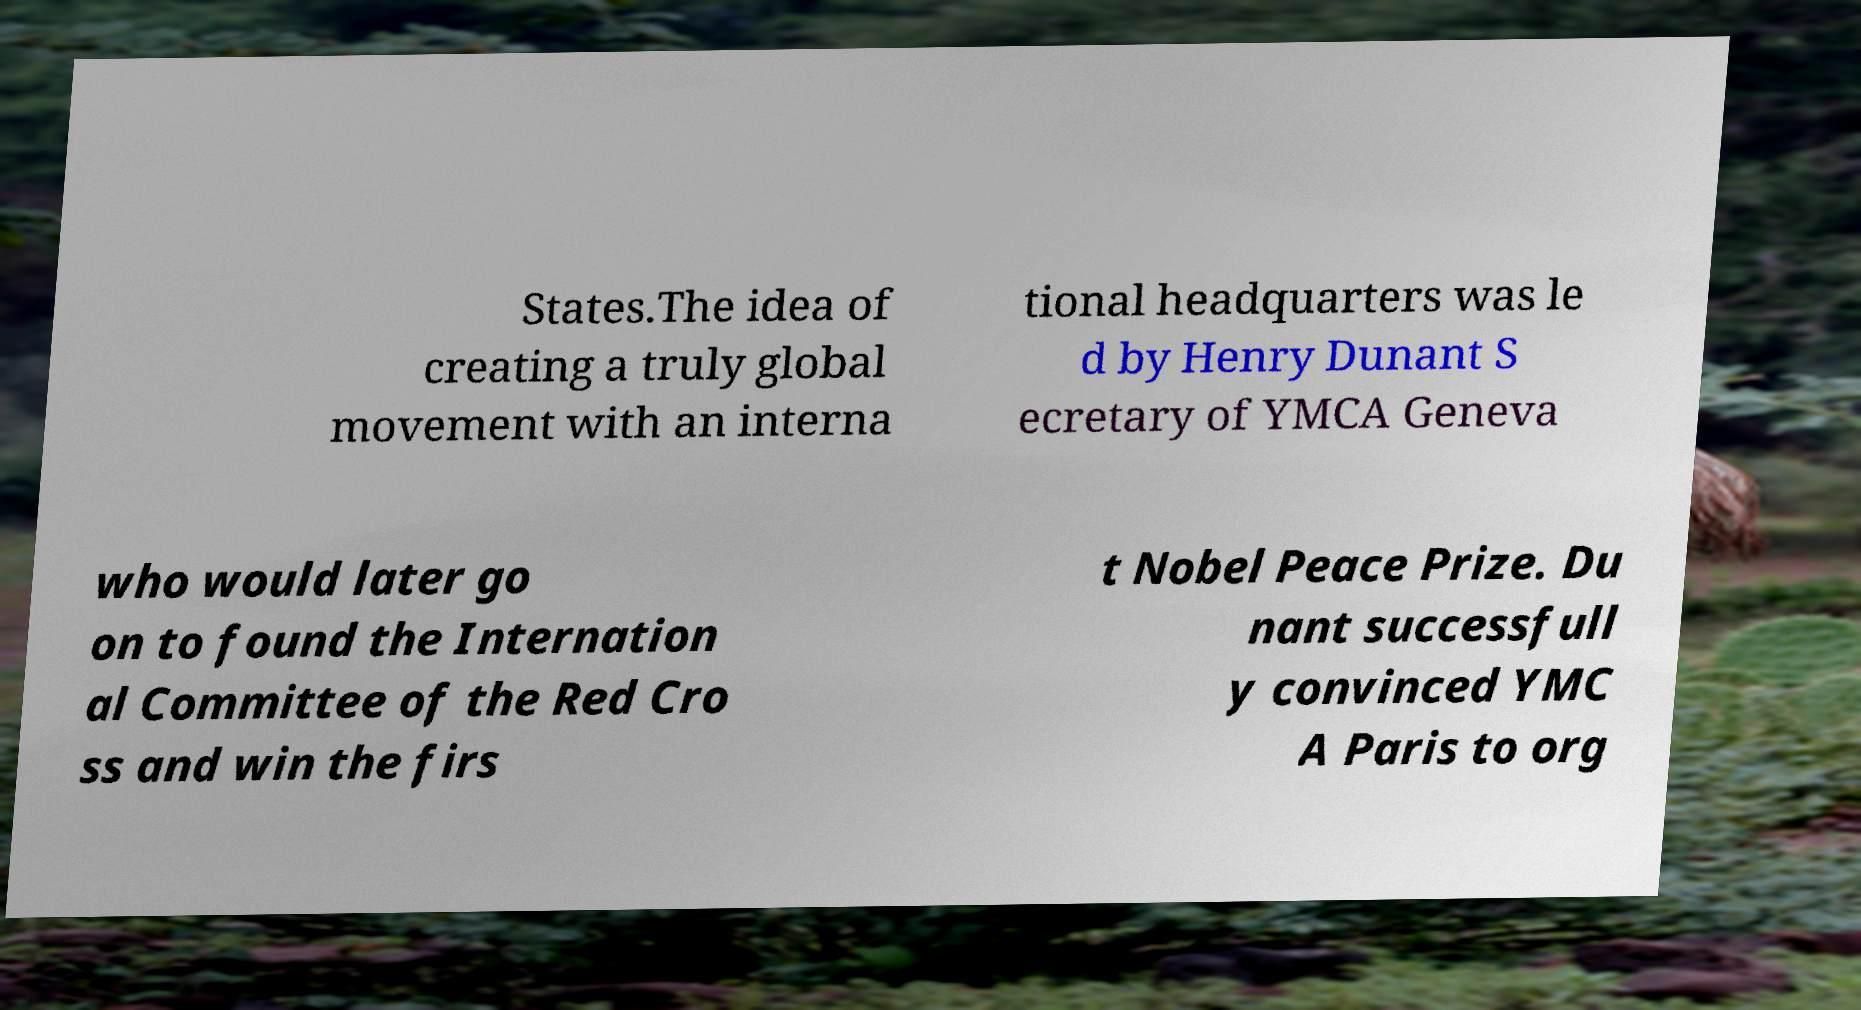Can you accurately transcribe the text from the provided image for me? States.The idea of creating a truly global movement with an interna tional headquarters was le d by Henry Dunant S ecretary of YMCA Geneva who would later go on to found the Internation al Committee of the Red Cro ss and win the firs t Nobel Peace Prize. Du nant successfull y convinced YMC A Paris to org 